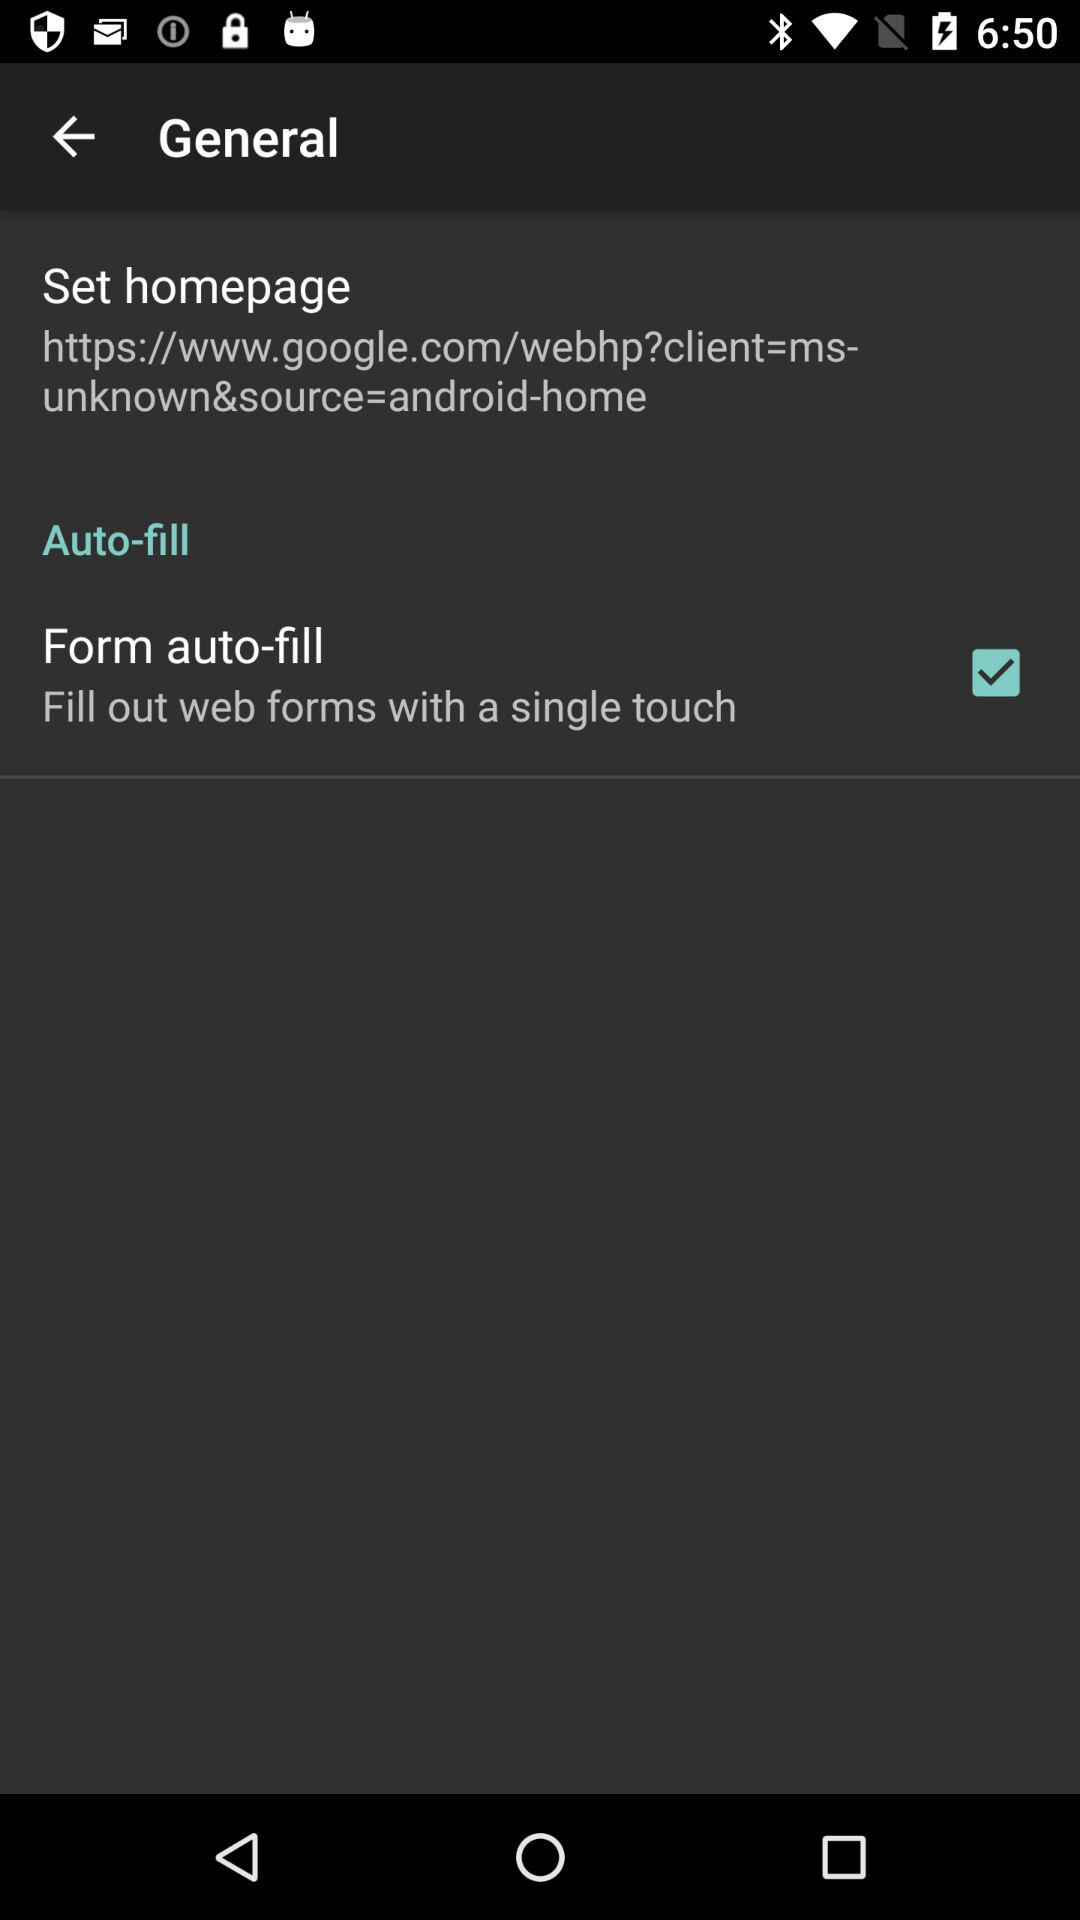What is the set web address of the homepage? The set web address of the homepage is https://www.google.com/webhp?client=ms- unknown&source=android-home. 